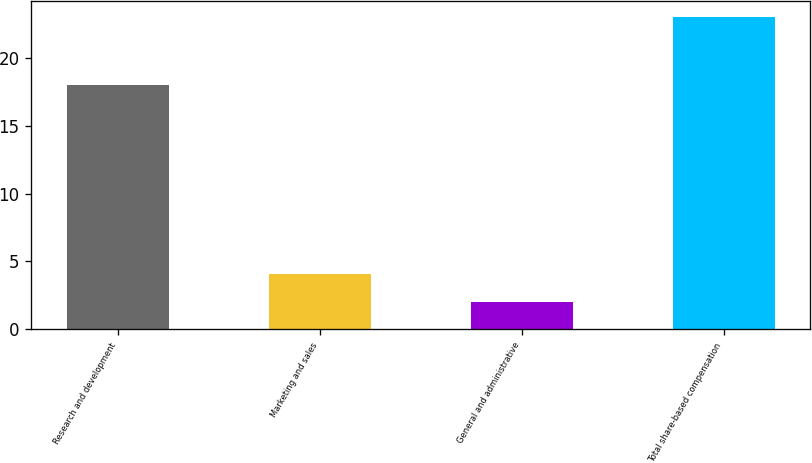<chart> <loc_0><loc_0><loc_500><loc_500><bar_chart><fcel>Research and development<fcel>Marketing and sales<fcel>General and administrative<fcel>Total share-based compensation<nl><fcel>18<fcel>4.1<fcel>2<fcel>23<nl></chart> 